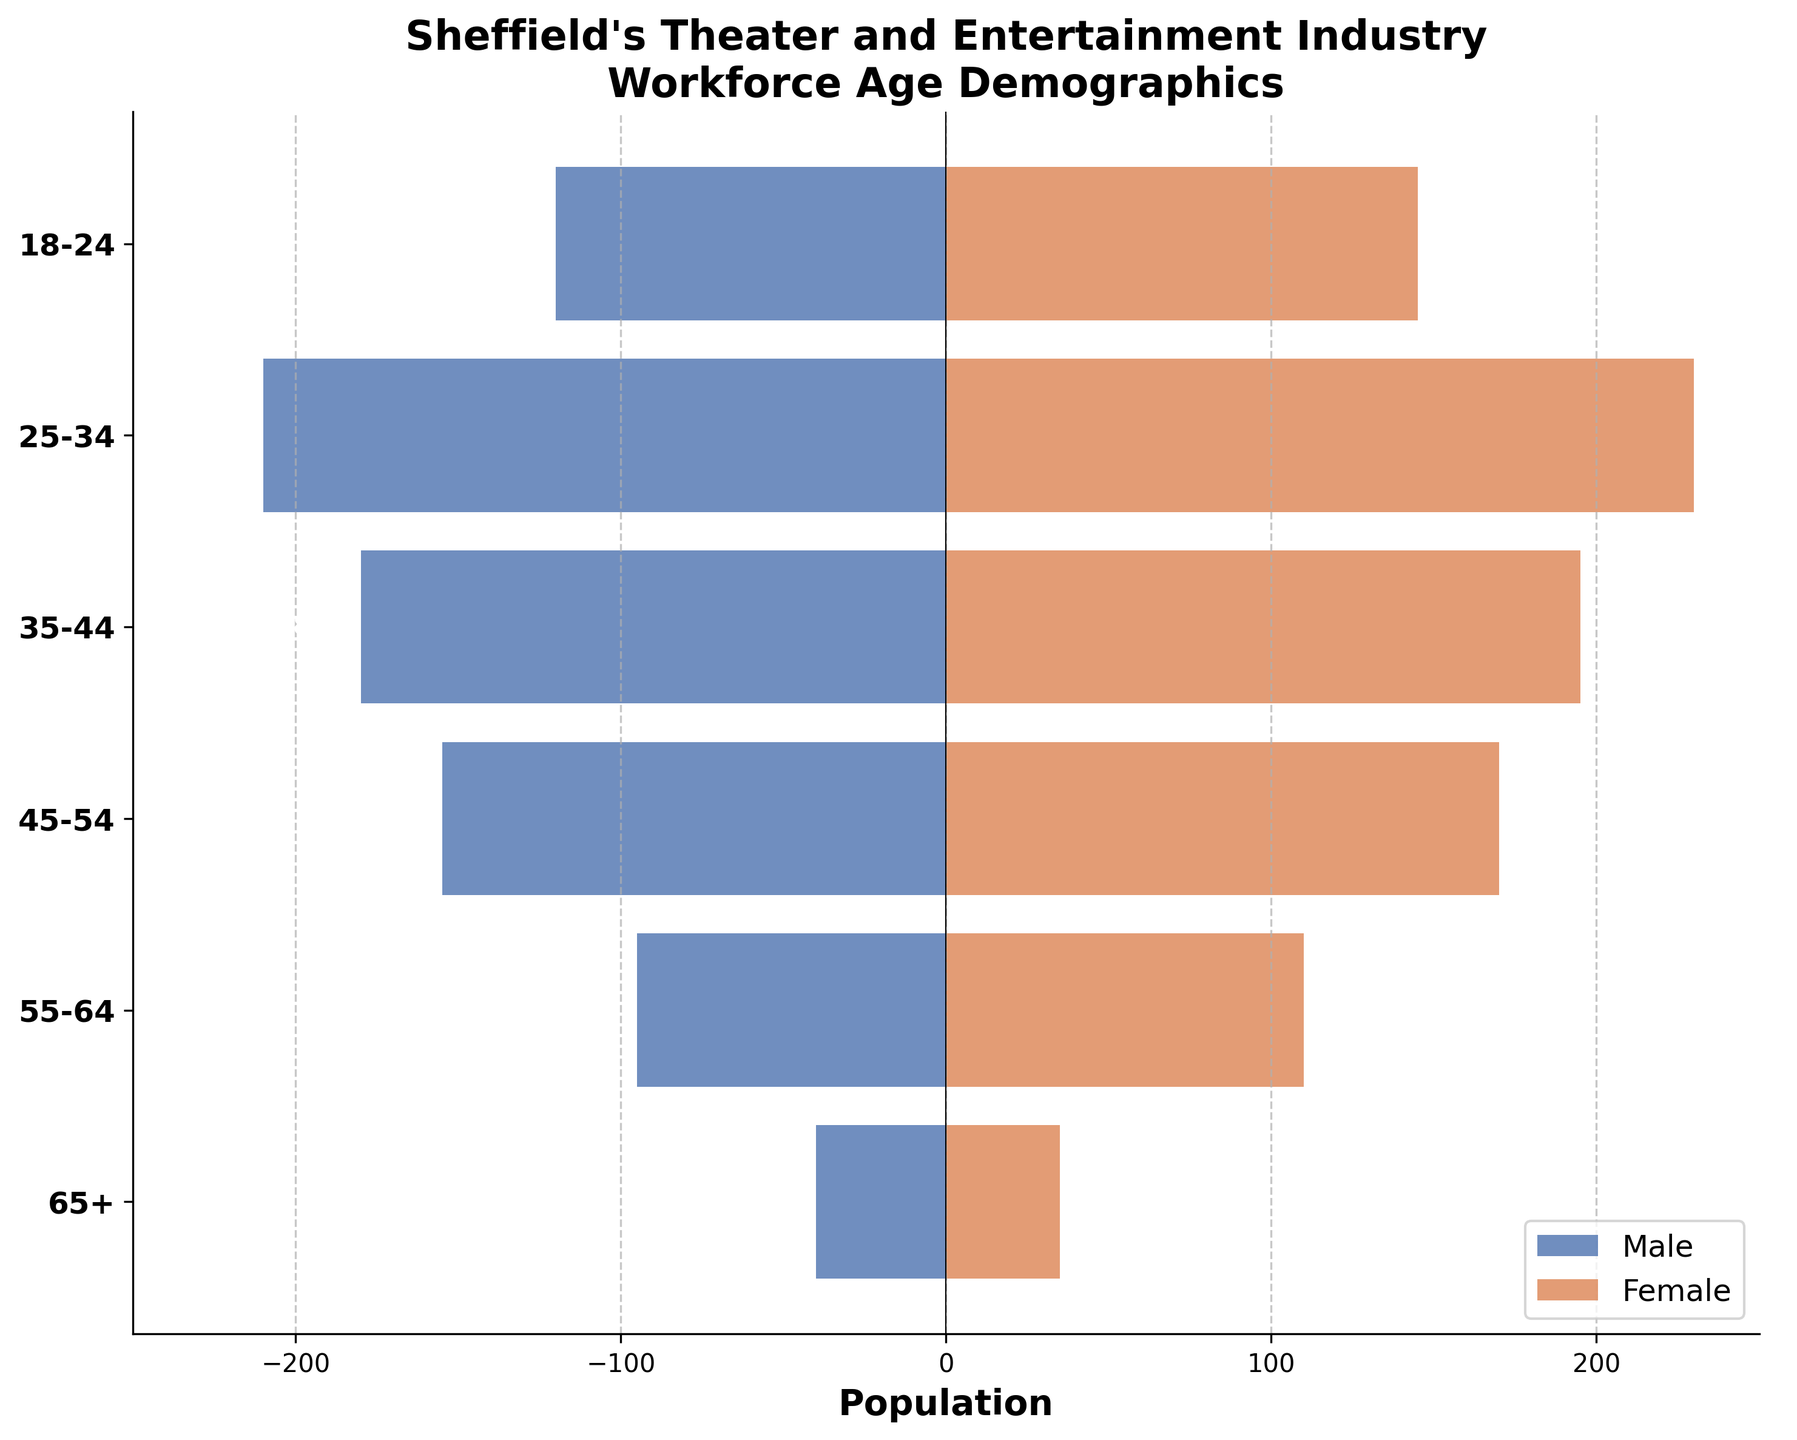What is the title of the figure? The title is usually located at the top of the plot. By looking at the figure, the text at the top reads "Sheffield's Theater and Entertainment Industry Workforce Age Demographics".
Answer: Sheffield's Theater and Entertainment Industry Workforce Age Demographics What age group has the highest number of females? By examining the lengths of the female bars, the age group 25-34 has the longest bar indicating the highest number of females.
Answer: 25-34 What is the difference in the number of males and females in the 35-44 age group? For the 35-44 age group, find the absolute values for males (180) and females (195). The difference is calculated as 195 - 180.
Answer: 15 How many more females are there than males in the 18-24 age group? For the 18-24 age group, females are 145 and males are 120. The difference between them is 145 - 120.
Answer: 25 Which age group has the fewest males? By looking at the lengths of the male bars, the age group 65+ is the shortest, indicating the fewest number of males.
Answer: 65+ How many people are in the 45-54 age group? Add the number of males (155) and females (170) in the 45-54 age group. The total is 155 + 170.
Answer: 325 What is the ratio of males to females in the 55-64 age group? The number of males is 95 and females is 110 in the 55-64 age group. The ratio is calculated as 95 / 110 and simplified.
Answer: 0.86 What is the total number of females across all age groups? Sum the number of females in each age group: 145 + 230 + 195 + 170 + 110 + 35.
Answer: 885 Which age group has the largest total workforce? Add the number of males and females in each age group and compare: 18-24 (265), 25-34 (440), 35-44 (375), 45-54 (325), 55-64 (205), 65+ (75). The 25-34 age group has the largest total.
Answer: 25-34 